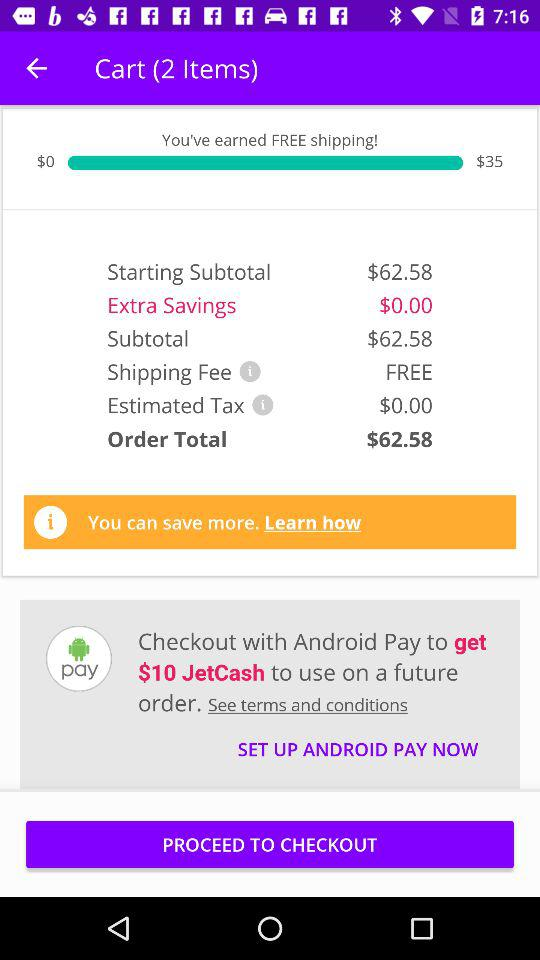What is the shipping fee? The shipping fee is free. 